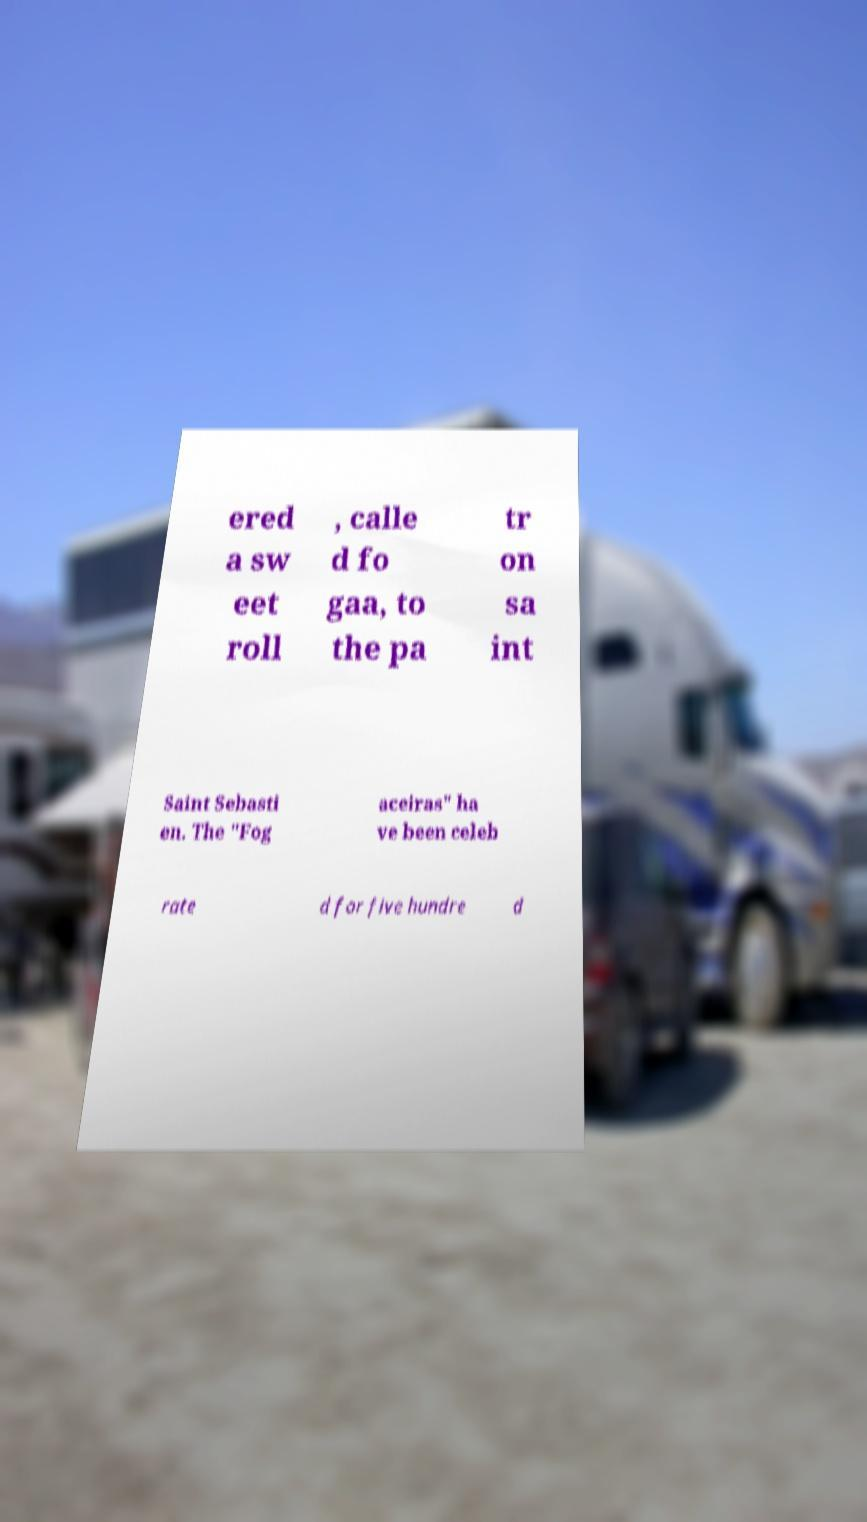I need the written content from this picture converted into text. Can you do that? ered a sw eet roll , calle d fo gaa, to the pa tr on sa int Saint Sebasti en. The "Fog aceiras" ha ve been celeb rate d for five hundre d 